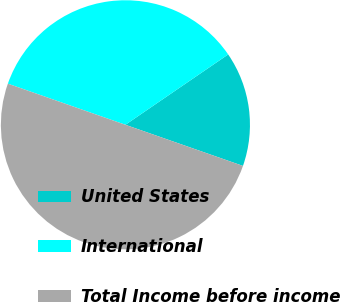<chart> <loc_0><loc_0><loc_500><loc_500><pie_chart><fcel>United States<fcel>International<fcel>Total Income before income<nl><fcel>14.91%<fcel>35.09%<fcel>50.0%<nl></chart> 